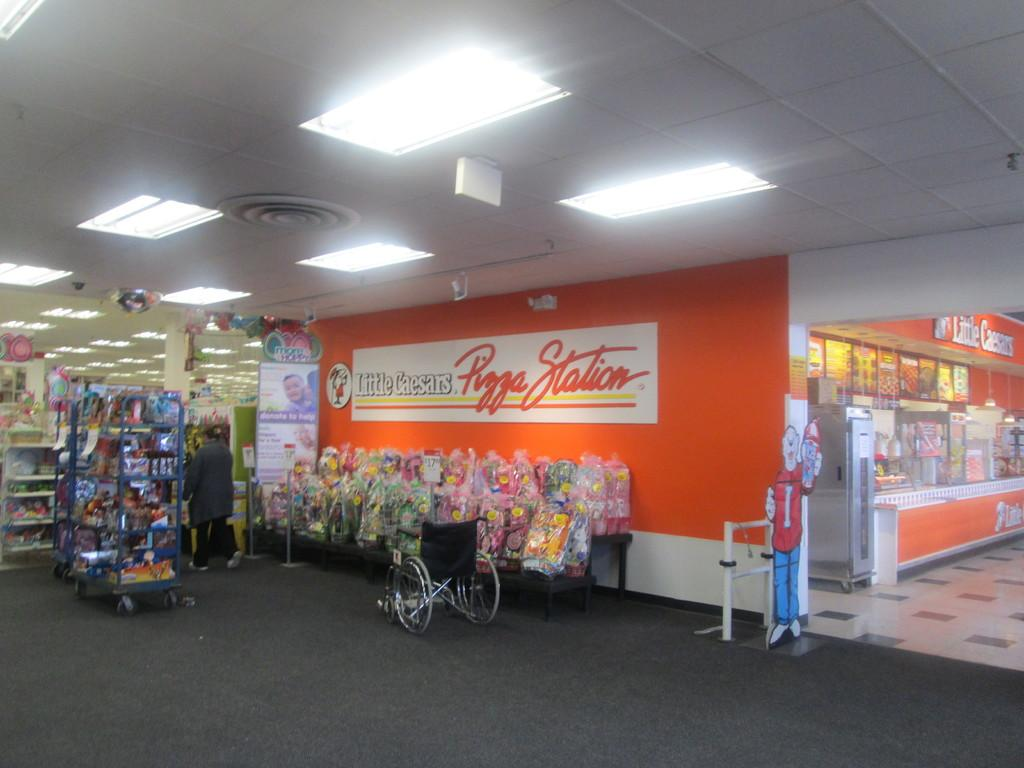<image>
Summarize the visual content of the image. A wheelchair is parked outside of a Little Cesears located inside of a store. 